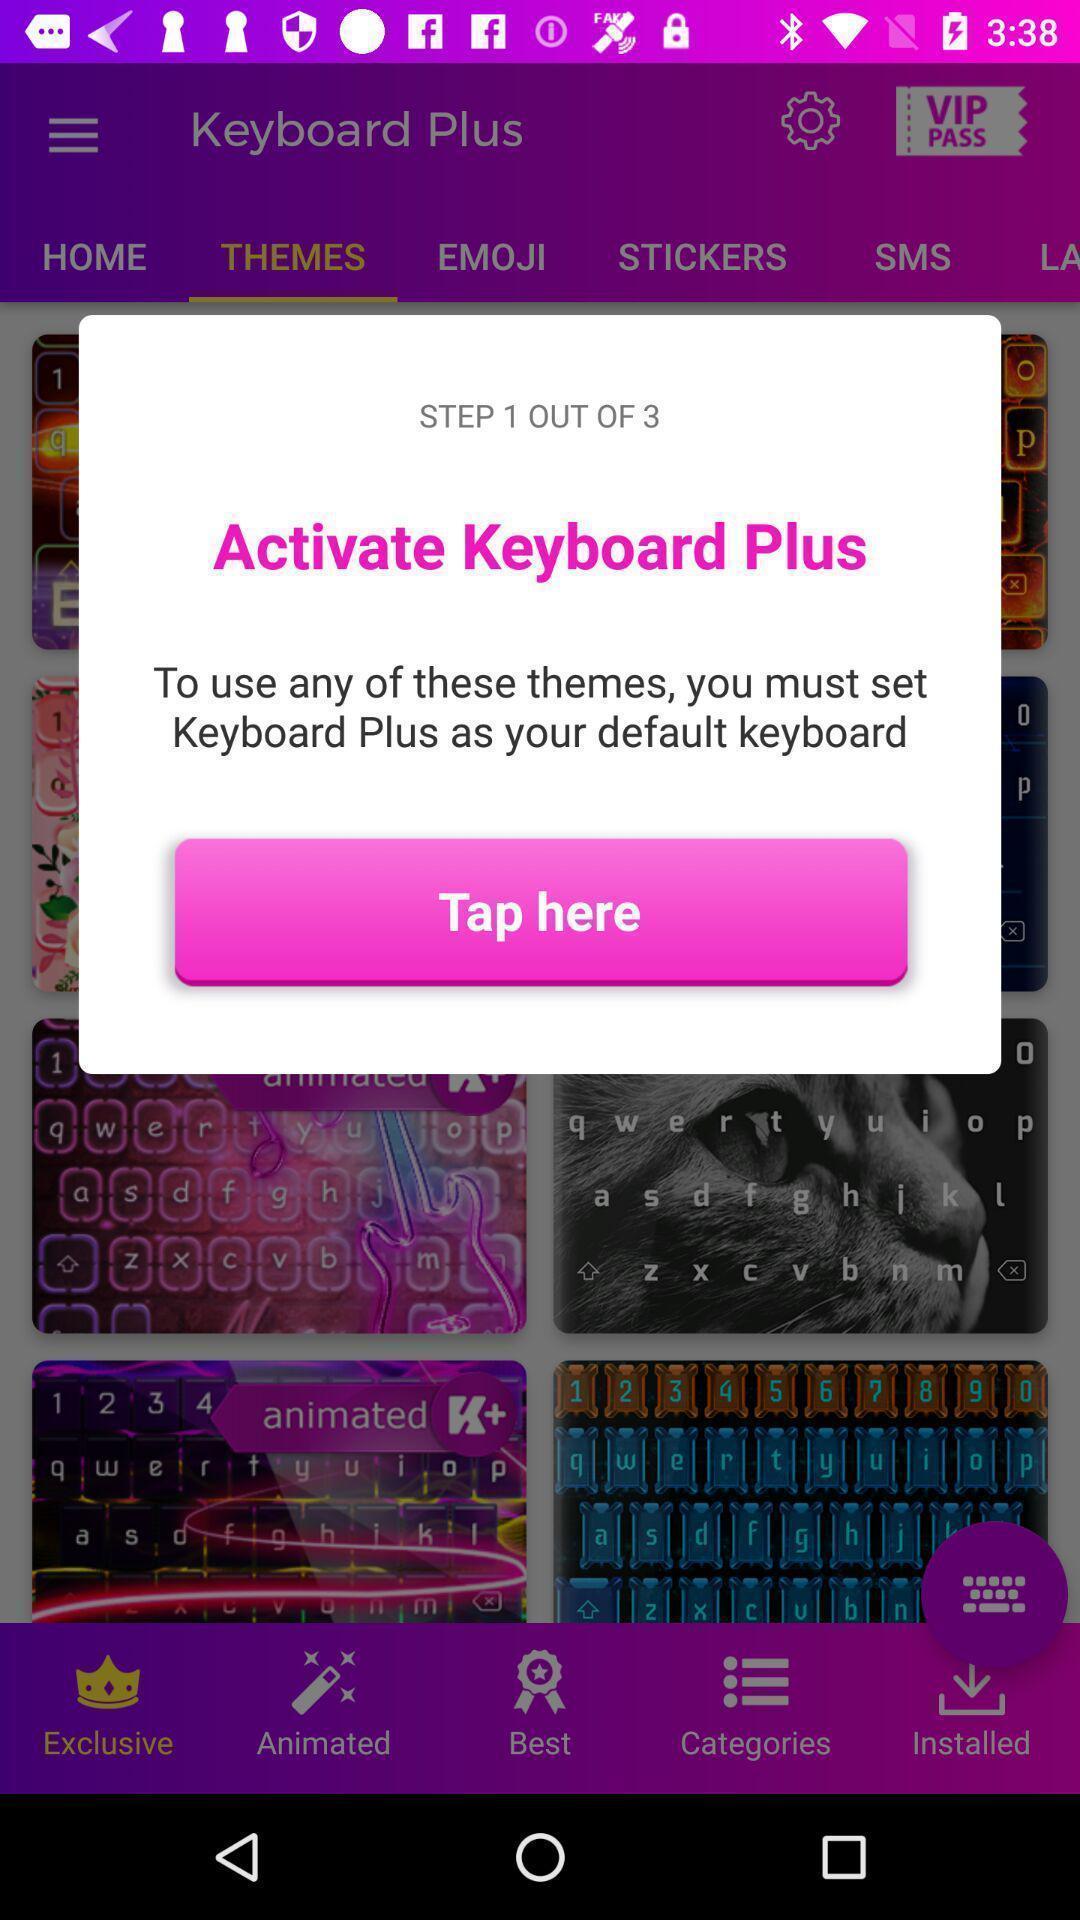Provide a description of this screenshot. Pop-up window showing a message to activate a feature. 